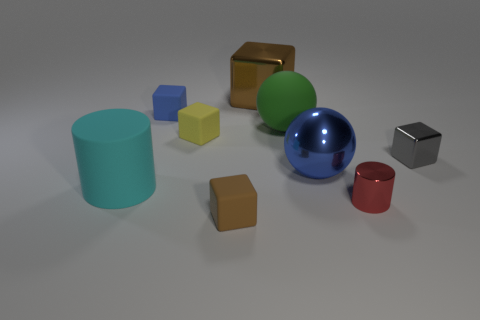Subtract all yellow blocks. How many blocks are left? 4 Subtract all yellow spheres. How many brown cubes are left? 2 Subtract 1 cylinders. How many cylinders are left? 1 Add 1 gray cylinders. How many objects exist? 10 Subtract all blue blocks. How many blocks are left? 4 Subtract all cubes. How many objects are left? 4 Add 7 small rubber objects. How many small rubber objects are left? 10 Add 3 tiny rubber cubes. How many tiny rubber cubes exist? 6 Subtract 1 cyan cylinders. How many objects are left? 8 Subtract all gray cylinders. Subtract all brown balls. How many cylinders are left? 2 